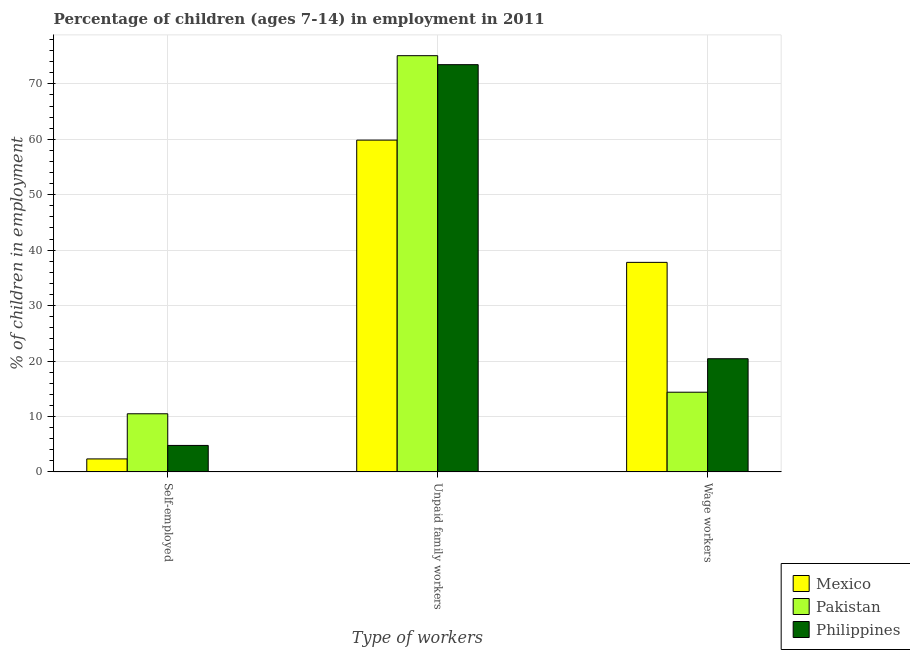How many different coloured bars are there?
Ensure brevity in your answer.  3. Are the number of bars on each tick of the X-axis equal?
Keep it short and to the point. Yes. How many bars are there on the 2nd tick from the left?
Give a very brief answer. 3. How many bars are there on the 2nd tick from the right?
Offer a very short reply. 3. What is the label of the 1st group of bars from the left?
Ensure brevity in your answer.  Self-employed. What is the percentage of self employed children in Philippines?
Your response must be concise. 4.78. Across all countries, what is the maximum percentage of children employed as wage workers?
Keep it short and to the point. 37.8. Across all countries, what is the minimum percentage of children employed as wage workers?
Give a very brief answer. 14.38. In which country was the percentage of children employed as unpaid family workers maximum?
Provide a short and direct response. Pakistan. In which country was the percentage of self employed children minimum?
Provide a succinct answer. Mexico. What is the total percentage of children employed as unpaid family workers in the graph?
Your answer should be compact. 208.39. What is the difference between the percentage of children employed as unpaid family workers in Mexico and that in Pakistan?
Ensure brevity in your answer.  -15.23. What is the difference between the percentage of children employed as wage workers in Pakistan and the percentage of self employed children in Philippines?
Ensure brevity in your answer.  9.6. What is the average percentage of children employed as unpaid family workers per country?
Give a very brief answer. 69.46. What is the difference between the percentage of children employed as wage workers and percentage of self employed children in Philippines?
Provide a succinct answer. 15.64. What is the ratio of the percentage of children employed as unpaid family workers in Mexico to that in Pakistan?
Provide a short and direct response. 0.8. What is the difference between the highest and the second highest percentage of self employed children?
Offer a terse response. 5.71. What is the difference between the highest and the lowest percentage of children employed as unpaid family workers?
Offer a terse response. 15.23. Is the sum of the percentage of self employed children in Philippines and Mexico greater than the maximum percentage of children employed as wage workers across all countries?
Your answer should be compact. No. What does the 1st bar from the left in Wage workers represents?
Provide a succinct answer. Mexico. What is the difference between two consecutive major ticks on the Y-axis?
Offer a very short reply. 10. Does the graph contain grids?
Your response must be concise. Yes. Where does the legend appear in the graph?
Offer a terse response. Bottom right. How many legend labels are there?
Give a very brief answer. 3. How are the legend labels stacked?
Keep it short and to the point. Vertical. What is the title of the graph?
Your response must be concise. Percentage of children (ages 7-14) in employment in 2011. Does "Least developed countries" appear as one of the legend labels in the graph?
Your answer should be very brief. No. What is the label or title of the X-axis?
Give a very brief answer. Type of workers. What is the label or title of the Y-axis?
Provide a short and direct response. % of children in employment. What is the % of children in employment of Mexico in Self-employed?
Provide a succinct answer. 2.35. What is the % of children in employment in Pakistan in Self-employed?
Make the answer very short. 10.49. What is the % of children in employment of Philippines in Self-employed?
Make the answer very short. 4.78. What is the % of children in employment of Mexico in Unpaid family workers?
Keep it short and to the point. 59.85. What is the % of children in employment of Pakistan in Unpaid family workers?
Your answer should be very brief. 75.08. What is the % of children in employment in Philippines in Unpaid family workers?
Offer a terse response. 73.46. What is the % of children in employment of Mexico in Wage workers?
Your response must be concise. 37.8. What is the % of children in employment of Pakistan in Wage workers?
Ensure brevity in your answer.  14.38. What is the % of children in employment in Philippines in Wage workers?
Give a very brief answer. 20.42. Across all Type of workers, what is the maximum % of children in employment in Mexico?
Keep it short and to the point. 59.85. Across all Type of workers, what is the maximum % of children in employment of Pakistan?
Offer a very short reply. 75.08. Across all Type of workers, what is the maximum % of children in employment in Philippines?
Your answer should be very brief. 73.46. Across all Type of workers, what is the minimum % of children in employment of Mexico?
Your answer should be very brief. 2.35. Across all Type of workers, what is the minimum % of children in employment of Pakistan?
Give a very brief answer. 10.49. Across all Type of workers, what is the minimum % of children in employment in Philippines?
Your answer should be compact. 4.78. What is the total % of children in employment in Pakistan in the graph?
Keep it short and to the point. 99.95. What is the total % of children in employment in Philippines in the graph?
Provide a short and direct response. 98.66. What is the difference between the % of children in employment of Mexico in Self-employed and that in Unpaid family workers?
Offer a terse response. -57.5. What is the difference between the % of children in employment of Pakistan in Self-employed and that in Unpaid family workers?
Ensure brevity in your answer.  -64.59. What is the difference between the % of children in employment in Philippines in Self-employed and that in Unpaid family workers?
Keep it short and to the point. -68.68. What is the difference between the % of children in employment in Mexico in Self-employed and that in Wage workers?
Offer a terse response. -35.45. What is the difference between the % of children in employment of Pakistan in Self-employed and that in Wage workers?
Ensure brevity in your answer.  -3.89. What is the difference between the % of children in employment in Philippines in Self-employed and that in Wage workers?
Give a very brief answer. -15.64. What is the difference between the % of children in employment of Mexico in Unpaid family workers and that in Wage workers?
Provide a short and direct response. 22.05. What is the difference between the % of children in employment of Pakistan in Unpaid family workers and that in Wage workers?
Your answer should be compact. 60.7. What is the difference between the % of children in employment in Philippines in Unpaid family workers and that in Wage workers?
Keep it short and to the point. 53.04. What is the difference between the % of children in employment of Mexico in Self-employed and the % of children in employment of Pakistan in Unpaid family workers?
Ensure brevity in your answer.  -72.73. What is the difference between the % of children in employment of Mexico in Self-employed and the % of children in employment of Philippines in Unpaid family workers?
Offer a terse response. -71.11. What is the difference between the % of children in employment in Pakistan in Self-employed and the % of children in employment in Philippines in Unpaid family workers?
Offer a terse response. -62.97. What is the difference between the % of children in employment in Mexico in Self-employed and the % of children in employment in Pakistan in Wage workers?
Provide a succinct answer. -12.03. What is the difference between the % of children in employment in Mexico in Self-employed and the % of children in employment in Philippines in Wage workers?
Offer a very short reply. -18.07. What is the difference between the % of children in employment in Pakistan in Self-employed and the % of children in employment in Philippines in Wage workers?
Your answer should be compact. -9.93. What is the difference between the % of children in employment of Mexico in Unpaid family workers and the % of children in employment of Pakistan in Wage workers?
Offer a very short reply. 45.47. What is the difference between the % of children in employment in Mexico in Unpaid family workers and the % of children in employment in Philippines in Wage workers?
Your answer should be very brief. 39.43. What is the difference between the % of children in employment in Pakistan in Unpaid family workers and the % of children in employment in Philippines in Wage workers?
Your response must be concise. 54.66. What is the average % of children in employment of Mexico per Type of workers?
Your answer should be very brief. 33.33. What is the average % of children in employment in Pakistan per Type of workers?
Provide a succinct answer. 33.32. What is the average % of children in employment of Philippines per Type of workers?
Provide a succinct answer. 32.89. What is the difference between the % of children in employment in Mexico and % of children in employment in Pakistan in Self-employed?
Make the answer very short. -8.14. What is the difference between the % of children in employment in Mexico and % of children in employment in Philippines in Self-employed?
Your response must be concise. -2.43. What is the difference between the % of children in employment in Pakistan and % of children in employment in Philippines in Self-employed?
Provide a succinct answer. 5.71. What is the difference between the % of children in employment of Mexico and % of children in employment of Pakistan in Unpaid family workers?
Give a very brief answer. -15.23. What is the difference between the % of children in employment in Mexico and % of children in employment in Philippines in Unpaid family workers?
Give a very brief answer. -13.61. What is the difference between the % of children in employment of Pakistan and % of children in employment of Philippines in Unpaid family workers?
Keep it short and to the point. 1.62. What is the difference between the % of children in employment of Mexico and % of children in employment of Pakistan in Wage workers?
Offer a terse response. 23.42. What is the difference between the % of children in employment in Mexico and % of children in employment in Philippines in Wage workers?
Keep it short and to the point. 17.38. What is the difference between the % of children in employment in Pakistan and % of children in employment in Philippines in Wage workers?
Offer a terse response. -6.04. What is the ratio of the % of children in employment of Mexico in Self-employed to that in Unpaid family workers?
Give a very brief answer. 0.04. What is the ratio of the % of children in employment of Pakistan in Self-employed to that in Unpaid family workers?
Provide a short and direct response. 0.14. What is the ratio of the % of children in employment of Philippines in Self-employed to that in Unpaid family workers?
Provide a short and direct response. 0.07. What is the ratio of the % of children in employment in Mexico in Self-employed to that in Wage workers?
Keep it short and to the point. 0.06. What is the ratio of the % of children in employment in Pakistan in Self-employed to that in Wage workers?
Provide a succinct answer. 0.73. What is the ratio of the % of children in employment of Philippines in Self-employed to that in Wage workers?
Your answer should be very brief. 0.23. What is the ratio of the % of children in employment in Mexico in Unpaid family workers to that in Wage workers?
Your answer should be very brief. 1.58. What is the ratio of the % of children in employment in Pakistan in Unpaid family workers to that in Wage workers?
Provide a short and direct response. 5.22. What is the ratio of the % of children in employment in Philippines in Unpaid family workers to that in Wage workers?
Keep it short and to the point. 3.6. What is the difference between the highest and the second highest % of children in employment of Mexico?
Your answer should be compact. 22.05. What is the difference between the highest and the second highest % of children in employment of Pakistan?
Provide a short and direct response. 60.7. What is the difference between the highest and the second highest % of children in employment of Philippines?
Your answer should be compact. 53.04. What is the difference between the highest and the lowest % of children in employment in Mexico?
Offer a very short reply. 57.5. What is the difference between the highest and the lowest % of children in employment of Pakistan?
Provide a succinct answer. 64.59. What is the difference between the highest and the lowest % of children in employment in Philippines?
Your answer should be very brief. 68.68. 